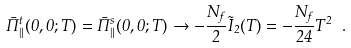<formula> <loc_0><loc_0><loc_500><loc_500>\bar { \Pi } ^ { t } _ { \| } ( 0 , 0 ; T ) = \bar { \Pi } ^ { s } _ { \| } ( 0 , 0 ; T ) \rightarrow - \frac { N _ { f } } { 2 } \tilde { I } _ { 2 } ( T ) = - \frac { N _ { f } } { 2 4 } T ^ { 2 } \ .</formula> 